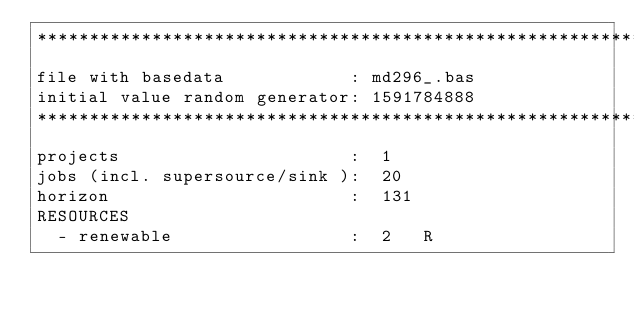Convert code to text. <code><loc_0><loc_0><loc_500><loc_500><_ObjectiveC_>************************************************************************
file with basedata            : md296_.bas
initial value random generator: 1591784888
************************************************************************
projects                      :  1
jobs (incl. supersource/sink ):  20
horizon                       :  131
RESOURCES
  - renewable                 :  2   R</code> 